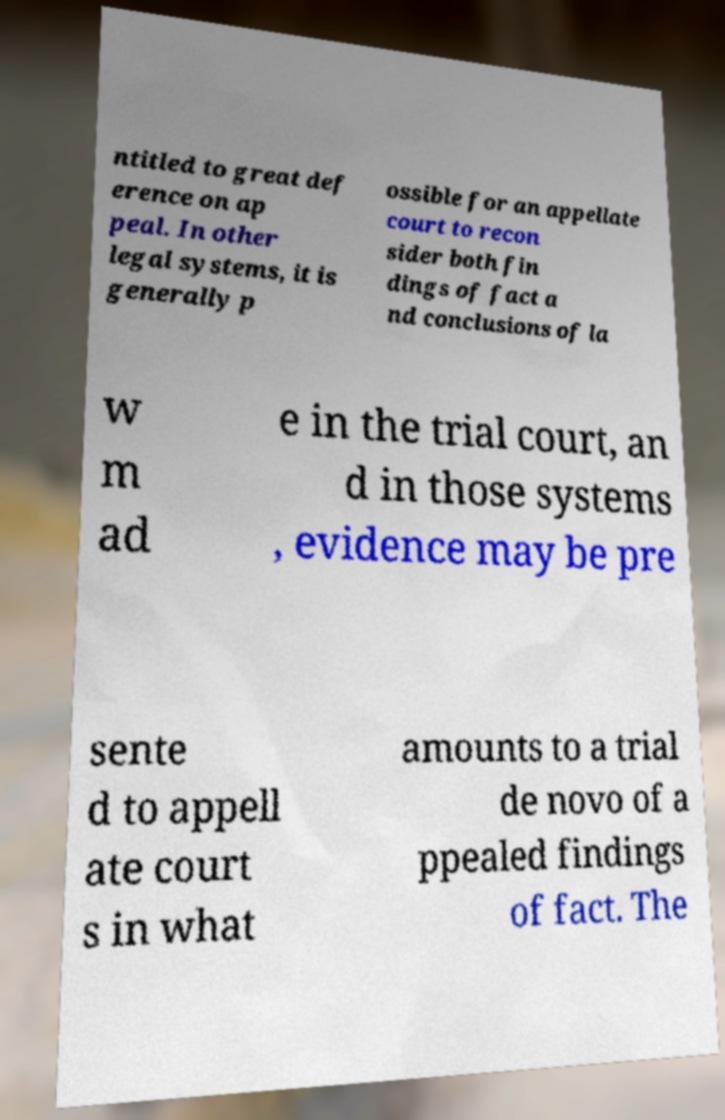Can you read and provide the text displayed in the image?This photo seems to have some interesting text. Can you extract and type it out for me? ntitled to great def erence on ap peal. In other legal systems, it is generally p ossible for an appellate court to recon sider both fin dings of fact a nd conclusions of la w m ad e in the trial court, an d in those systems , evidence may be pre sente d to appell ate court s in what amounts to a trial de novo of a ppealed findings of fact. The 